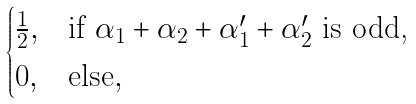Convert formula to latex. <formula><loc_0><loc_0><loc_500><loc_500>\begin{cases} \frac { 1 } { 2 } , & \text {if $\alpha_{1} + \alpha_{2} + \alpha^{\prime}_{1} + \alpha^{\prime}_{2}$ is odd,} \\ 0 , & \text {else} , \end{cases}</formula> 